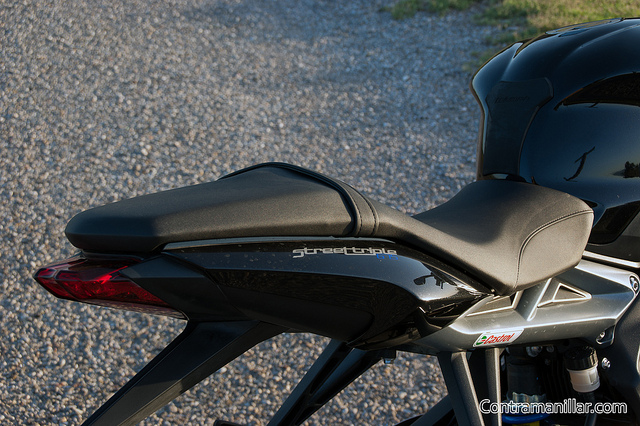Please extract the text content from this image. Contramanillar.com Castrol Streettriple 